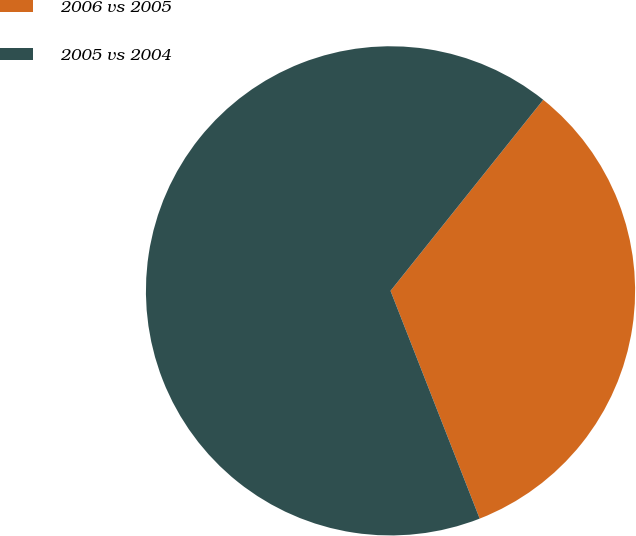Convert chart. <chart><loc_0><loc_0><loc_500><loc_500><pie_chart><fcel>2006 vs 2005<fcel>2005 vs 2004<nl><fcel>33.33%<fcel>66.67%<nl></chart> 